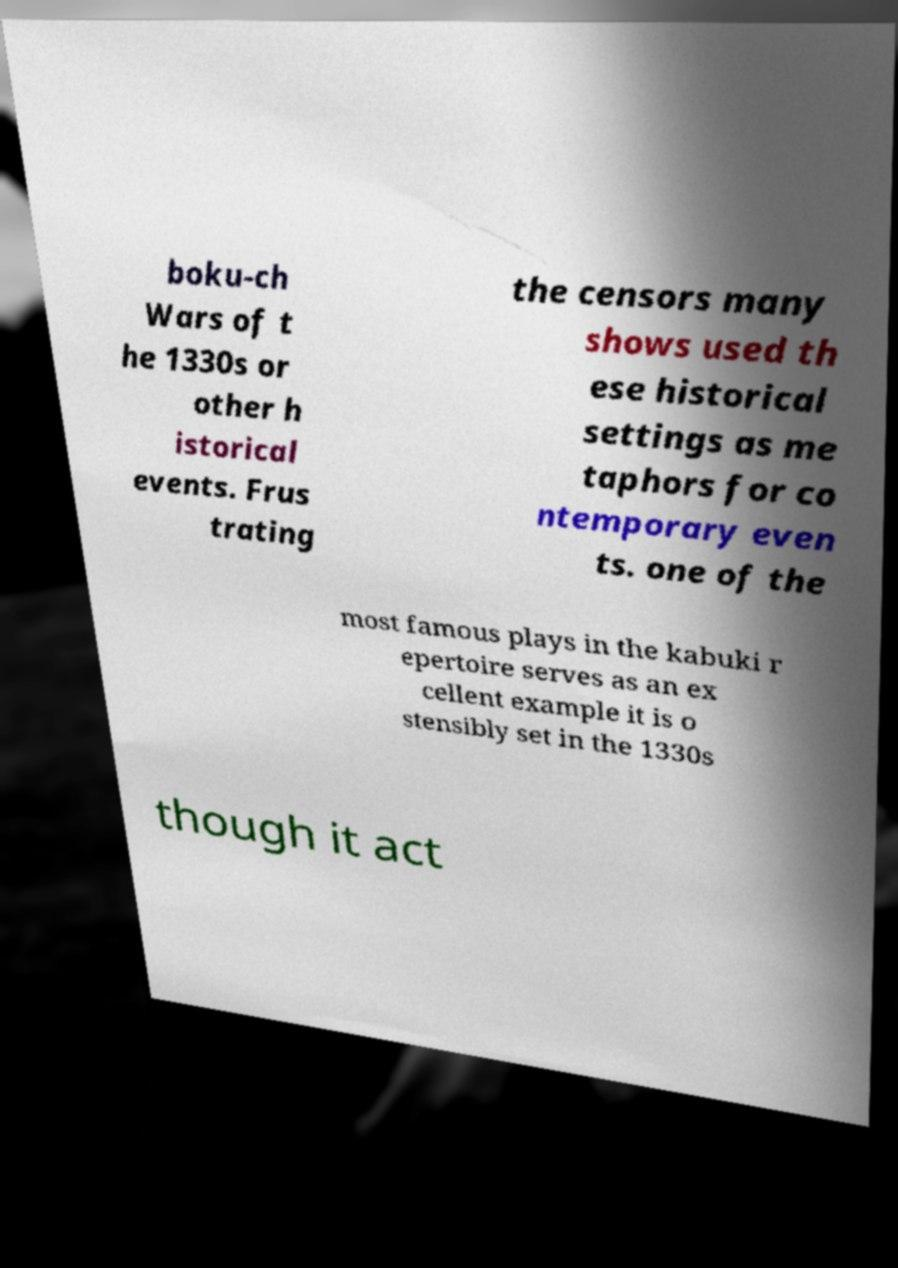Could you assist in decoding the text presented in this image and type it out clearly? boku-ch Wars of t he 1330s or other h istorical events. Frus trating the censors many shows used th ese historical settings as me taphors for co ntemporary even ts. one of the most famous plays in the kabuki r epertoire serves as an ex cellent example it is o stensibly set in the 1330s though it act 